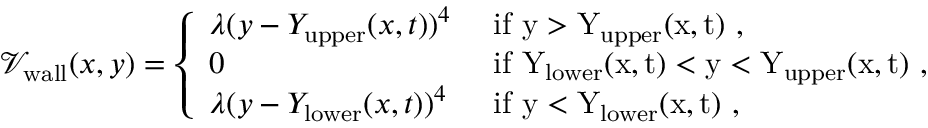Convert formula to latex. <formula><loc_0><loc_0><loc_500><loc_500>\begin{array} { r } { \mathcal { V } _ { w a l l } ( x , y ) = \left \{ \begin{array} { l l } { \lambda ( y - Y _ { u p p e r } ( x , t ) ) ^ { 4 } } & { i f y > Y _ { \mathrm } { u p p e r } ( x , t ) , } \\ { 0 } & { i f Y _ { \mathrm } { l o w e r } ( x , t ) < y < Y _ { \mathrm } { u p p e r } ( x , t ) , } \\ { \lambda ( y - Y _ { l o w e r } ( x , t ) ) ^ { 4 } } & { i f y < Y _ { \mathrm } { l o w e r } ( x , t ) , } \end{array} } \end{array}</formula> 